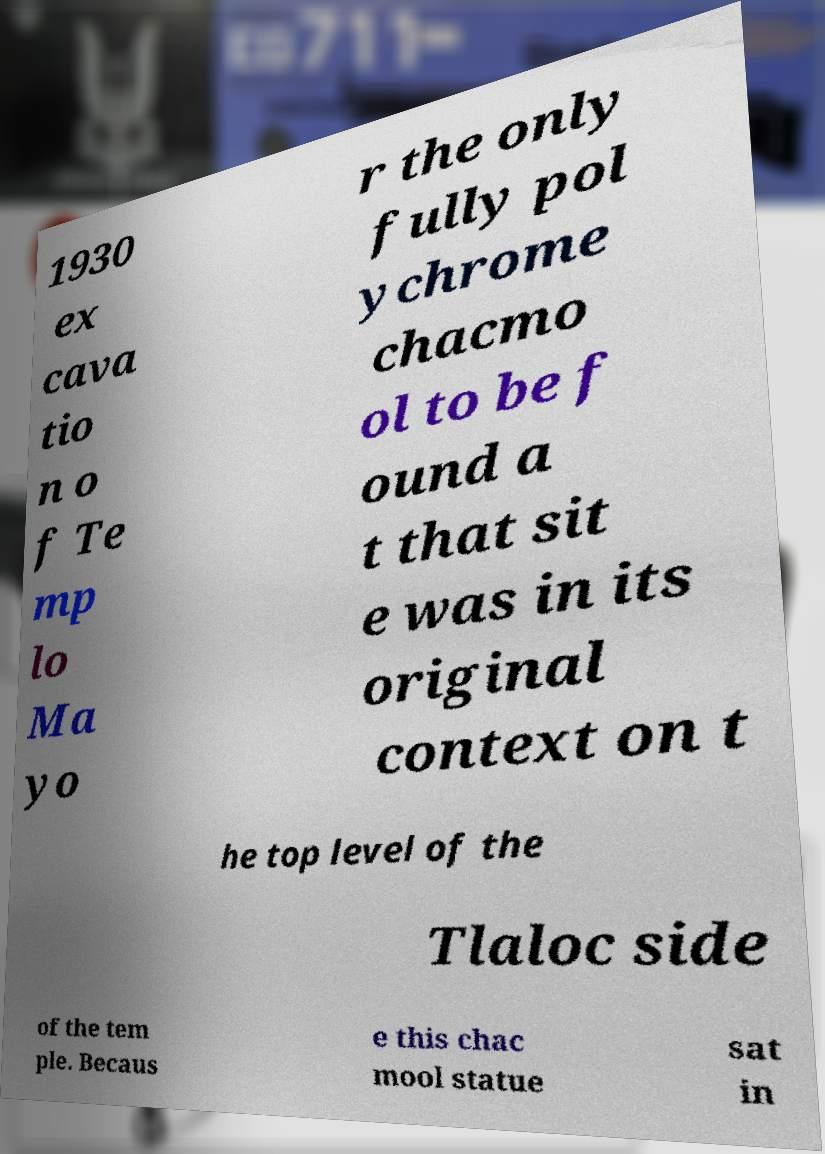There's text embedded in this image that I need extracted. Can you transcribe it verbatim? 1930 ex cava tio n o f Te mp lo Ma yo r the only fully pol ychrome chacmo ol to be f ound a t that sit e was in its original context on t he top level of the Tlaloc side of the tem ple. Becaus e this chac mool statue sat in 